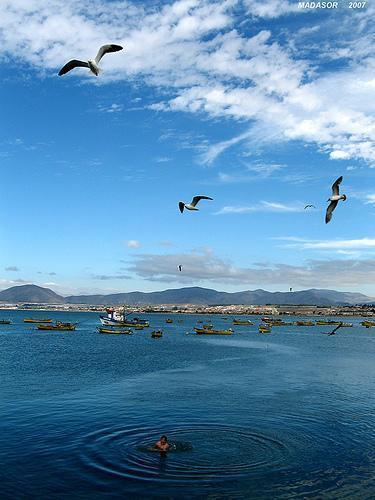How many boats are in the picture?
Give a very brief answer. 1. 